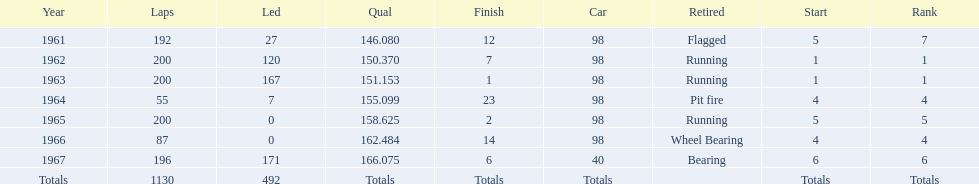Would you mind parsing the complete table? {'header': ['Year', 'Laps', 'Led', 'Qual', 'Finish', 'Car', 'Retired', 'Start', 'Rank'], 'rows': [['1961', '192', '27', '146.080', '12', '98', 'Flagged', '5', '7'], ['1962', '200', '120', '150.370', '7', '98', 'Running', '1', '1'], ['1963', '200', '167', '151.153', '1', '98', 'Running', '1', '1'], ['1964', '55', '7', '155.099', '23', '98', 'Pit fire', '4', '4'], ['1965', '200', '0', '158.625', '2', '98', 'Running', '5', '5'], ['1966', '87', '0', '162.484', '14', '98', 'Wheel Bearing', '4', '4'], ['1967', '196', '171', '166.075', '6', '40', 'Bearing', '6', '6'], ['Totals', '1130', '492', 'Totals', 'Totals', 'Totals', '', 'Totals', 'Totals']]} What car ranked #1 from 1962-1963? 98. 